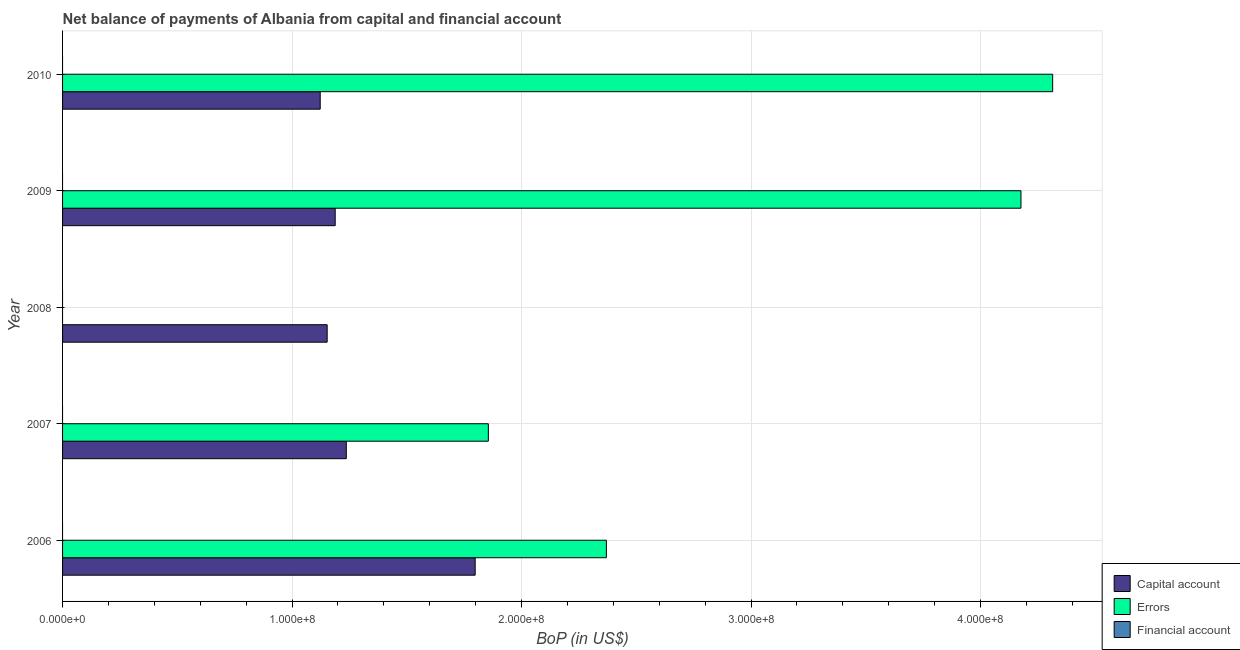How many different coloured bars are there?
Your response must be concise. 2. Are the number of bars per tick equal to the number of legend labels?
Ensure brevity in your answer.  No. Are the number of bars on each tick of the Y-axis equal?
Offer a terse response. No. How many bars are there on the 1st tick from the top?
Your answer should be very brief. 2. How many bars are there on the 1st tick from the bottom?
Your answer should be compact. 2. What is the label of the 3rd group of bars from the top?
Ensure brevity in your answer.  2008. What is the amount of errors in 2009?
Your answer should be very brief. 4.18e+08. Across all years, what is the maximum amount of net capital account?
Provide a succinct answer. 1.80e+08. Across all years, what is the minimum amount of errors?
Provide a short and direct response. 0. What is the total amount of errors in the graph?
Keep it short and to the point. 1.27e+09. What is the difference between the amount of net capital account in 2007 and that in 2010?
Your answer should be compact. 1.14e+07. What is the average amount of net capital account per year?
Your answer should be very brief. 1.30e+08. In the year 2007, what is the difference between the amount of errors and amount of net capital account?
Your answer should be compact. 6.19e+07. In how many years, is the amount of errors greater than 380000000 US$?
Ensure brevity in your answer.  2. What is the ratio of the amount of errors in 2007 to that in 2010?
Make the answer very short. 0.43. Is the amount of net capital account in 2008 less than that in 2010?
Make the answer very short. No. Is the difference between the amount of net capital account in 2007 and 2010 greater than the difference between the amount of errors in 2007 and 2010?
Make the answer very short. Yes. What is the difference between the highest and the second highest amount of errors?
Provide a succinct answer. 1.38e+07. What is the difference between the highest and the lowest amount of errors?
Provide a succinct answer. 4.31e+08. In how many years, is the amount of net capital account greater than the average amount of net capital account taken over all years?
Provide a short and direct response. 1. Is it the case that in every year, the sum of the amount of net capital account and amount of errors is greater than the amount of financial account?
Provide a succinct answer. Yes. How many bars are there?
Give a very brief answer. 9. Are all the bars in the graph horizontal?
Make the answer very short. Yes. How many years are there in the graph?
Offer a very short reply. 5. Does the graph contain any zero values?
Keep it short and to the point. Yes. Where does the legend appear in the graph?
Ensure brevity in your answer.  Bottom right. What is the title of the graph?
Provide a succinct answer. Net balance of payments of Albania from capital and financial account. What is the label or title of the X-axis?
Your answer should be very brief. BoP (in US$). What is the BoP (in US$) of Capital account in 2006?
Keep it short and to the point. 1.80e+08. What is the BoP (in US$) of Errors in 2006?
Offer a very short reply. 2.37e+08. What is the BoP (in US$) in Financial account in 2006?
Give a very brief answer. 0. What is the BoP (in US$) in Capital account in 2007?
Offer a very short reply. 1.24e+08. What is the BoP (in US$) of Errors in 2007?
Provide a short and direct response. 1.86e+08. What is the BoP (in US$) in Financial account in 2007?
Keep it short and to the point. 0. What is the BoP (in US$) of Capital account in 2008?
Give a very brief answer. 1.15e+08. What is the BoP (in US$) in Errors in 2008?
Offer a terse response. 0. What is the BoP (in US$) of Financial account in 2008?
Provide a short and direct response. 0. What is the BoP (in US$) in Capital account in 2009?
Keep it short and to the point. 1.19e+08. What is the BoP (in US$) in Errors in 2009?
Offer a very short reply. 4.18e+08. What is the BoP (in US$) of Capital account in 2010?
Offer a very short reply. 1.12e+08. What is the BoP (in US$) of Errors in 2010?
Provide a succinct answer. 4.31e+08. Across all years, what is the maximum BoP (in US$) in Capital account?
Make the answer very short. 1.80e+08. Across all years, what is the maximum BoP (in US$) of Errors?
Offer a very short reply. 4.31e+08. Across all years, what is the minimum BoP (in US$) of Capital account?
Give a very brief answer. 1.12e+08. What is the total BoP (in US$) in Capital account in the graph?
Your answer should be very brief. 6.50e+08. What is the total BoP (in US$) of Errors in the graph?
Ensure brevity in your answer.  1.27e+09. What is the difference between the BoP (in US$) in Capital account in 2006 and that in 2007?
Make the answer very short. 5.62e+07. What is the difference between the BoP (in US$) of Errors in 2006 and that in 2007?
Your answer should be very brief. 5.14e+07. What is the difference between the BoP (in US$) of Capital account in 2006 and that in 2008?
Your answer should be compact. 6.45e+07. What is the difference between the BoP (in US$) of Capital account in 2006 and that in 2009?
Your answer should be very brief. 6.10e+07. What is the difference between the BoP (in US$) of Errors in 2006 and that in 2009?
Your answer should be compact. -1.81e+08. What is the difference between the BoP (in US$) in Capital account in 2006 and that in 2010?
Provide a short and direct response. 6.75e+07. What is the difference between the BoP (in US$) of Errors in 2006 and that in 2010?
Provide a succinct answer. -1.94e+08. What is the difference between the BoP (in US$) in Capital account in 2007 and that in 2008?
Your answer should be compact. 8.34e+06. What is the difference between the BoP (in US$) of Capital account in 2007 and that in 2009?
Offer a very short reply. 4.84e+06. What is the difference between the BoP (in US$) in Errors in 2007 and that in 2009?
Your answer should be compact. -2.32e+08. What is the difference between the BoP (in US$) of Capital account in 2007 and that in 2010?
Keep it short and to the point. 1.14e+07. What is the difference between the BoP (in US$) of Errors in 2007 and that in 2010?
Provide a short and direct response. -2.46e+08. What is the difference between the BoP (in US$) in Capital account in 2008 and that in 2009?
Offer a very short reply. -3.50e+06. What is the difference between the BoP (in US$) of Capital account in 2008 and that in 2010?
Make the answer very short. 3.03e+06. What is the difference between the BoP (in US$) in Capital account in 2009 and that in 2010?
Your response must be concise. 6.53e+06. What is the difference between the BoP (in US$) in Errors in 2009 and that in 2010?
Ensure brevity in your answer.  -1.38e+07. What is the difference between the BoP (in US$) in Capital account in 2006 and the BoP (in US$) in Errors in 2007?
Provide a succinct answer. -5.74e+06. What is the difference between the BoP (in US$) of Capital account in 2006 and the BoP (in US$) of Errors in 2009?
Your answer should be very brief. -2.38e+08. What is the difference between the BoP (in US$) of Capital account in 2006 and the BoP (in US$) of Errors in 2010?
Provide a short and direct response. -2.52e+08. What is the difference between the BoP (in US$) in Capital account in 2007 and the BoP (in US$) in Errors in 2009?
Your answer should be very brief. -2.94e+08. What is the difference between the BoP (in US$) of Capital account in 2007 and the BoP (in US$) of Errors in 2010?
Ensure brevity in your answer.  -3.08e+08. What is the difference between the BoP (in US$) of Capital account in 2008 and the BoP (in US$) of Errors in 2009?
Keep it short and to the point. -3.02e+08. What is the difference between the BoP (in US$) of Capital account in 2008 and the BoP (in US$) of Errors in 2010?
Make the answer very short. -3.16e+08. What is the difference between the BoP (in US$) in Capital account in 2009 and the BoP (in US$) in Errors in 2010?
Offer a very short reply. -3.13e+08. What is the average BoP (in US$) in Capital account per year?
Your answer should be very brief. 1.30e+08. What is the average BoP (in US$) in Errors per year?
Ensure brevity in your answer.  2.54e+08. In the year 2006, what is the difference between the BoP (in US$) of Capital account and BoP (in US$) of Errors?
Give a very brief answer. -5.72e+07. In the year 2007, what is the difference between the BoP (in US$) in Capital account and BoP (in US$) in Errors?
Offer a terse response. -6.19e+07. In the year 2009, what is the difference between the BoP (in US$) in Capital account and BoP (in US$) in Errors?
Keep it short and to the point. -2.99e+08. In the year 2010, what is the difference between the BoP (in US$) in Capital account and BoP (in US$) in Errors?
Offer a very short reply. -3.19e+08. What is the ratio of the BoP (in US$) of Capital account in 2006 to that in 2007?
Give a very brief answer. 1.45. What is the ratio of the BoP (in US$) in Errors in 2006 to that in 2007?
Your answer should be compact. 1.28. What is the ratio of the BoP (in US$) in Capital account in 2006 to that in 2008?
Offer a very short reply. 1.56. What is the ratio of the BoP (in US$) of Capital account in 2006 to that in 2009?
Give a very brief answer. 1.51. What is the ratio of the BoP (in US$) of Errors in 2006 to that in 2009?
Make the answer very short. 0.57. What is the ratio of the BoP (in US$) in Capital account in 2006 to that in 2010?
Provide a succinct answer. 1.6. What is the ratio of the BoP (in US$) in Errors in 2006 to that in 2010?
Your response must be concise. 0.55. What is the ratio of the BoP (in US$) of Capital account in 2007 to that in 2008?
Keep it short and to the point. 1.07. What is the ratio of the BoP (in US$) in Capital account in 2007 to that in 2009?
Offer a terse response. 1.04. What is the ratio of the BoP (in US$) of Errors in 2007 to that in 2009?
Your response must be concise. 0.44. What is the ratio of the BoP (in US$) of Capital account in 2007 to that in 2010?
Your response must be concise. 1.1. What is the ratio of the BoP (in US$) of Errors in 2007 to that in 2010?
Your answer should be very brief. 0.43. What is the ratio of the BoP (in US$) in Capital account in 2008 to that in 2009?
Offer a terse response. 0.97. What is the ratio of the BoP (in US$) of Capital account in 2009 to that in 2010?
Provide a succinct answer. 1.06. What is the difference between the highest and the second highest BoP (in US$) of Capital account?
Offer a very short reply. 5.62e+07. What is the difference between the highest and the second highest BoP (in US$) of Errors?
Give a very brief answer. 1.38e+07. What is the difference between the highest and the lowest BoP (in US$) of Capital account?
Your response must be concise. 6.75e+07. What is the difference between the highest and the lowest BoP (in US$) of Errors?
Give a very brief answer. 4.31e+08. 